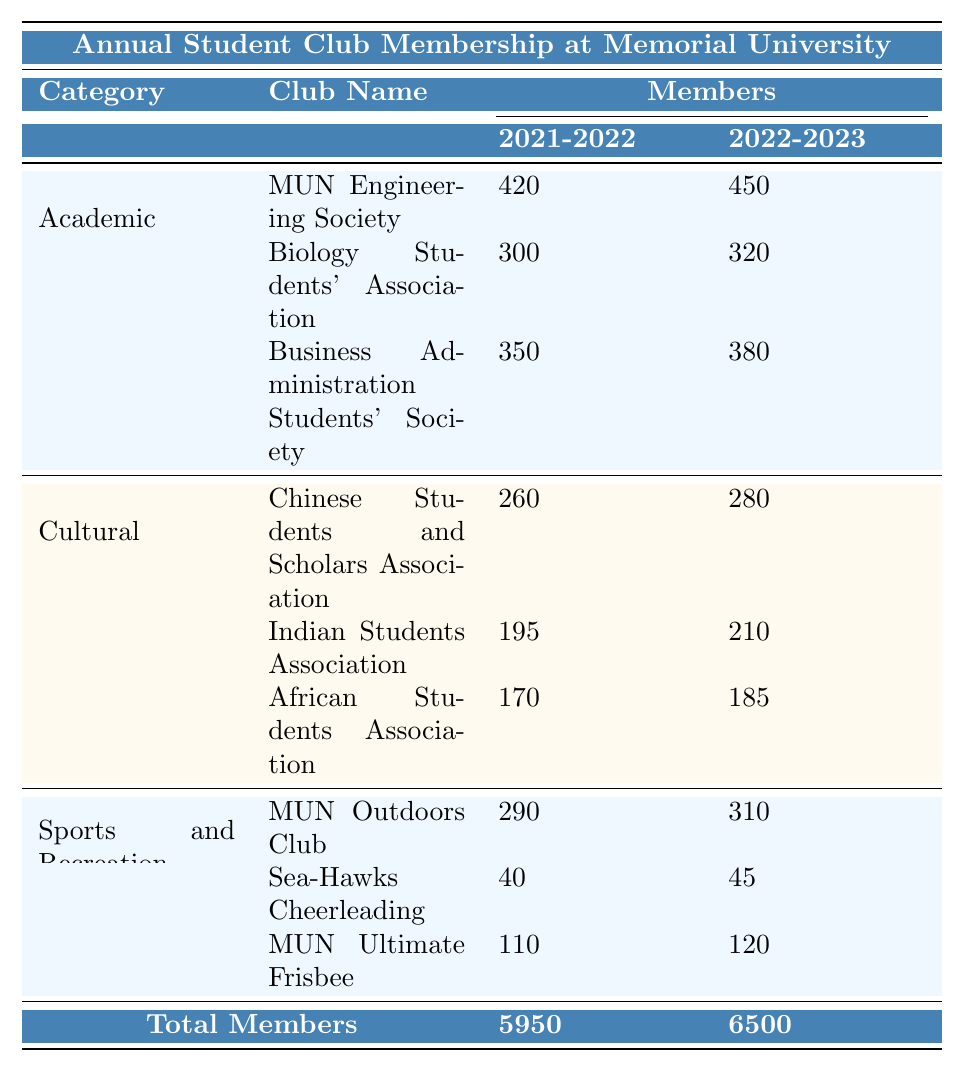What was the total number of clubs at Memorial University in the academic year 2022-2023? The table clearly states that the total number of clubs for the academic year 2022-2023 is 150.
Answer: 150 Which club had the highest membership in the Cultural category for the year 2022-2023? In the Cultural category for 2022-2023, the Chinese Students and Scholars Association had 280 members, which is higher than the other clubs in that category.
Answer: Chinese Students and Scholars Association How many members were in the Sports and Recreation category in 2021-2022? The total number of members in the Sports and Recreation category for 2021-2022 is stated as 2000 in the table.
Answer: 2000 What is the difference in total membership between Academic clubs from 2021-2022 and 2022-2023? In 2021-2022, the total membership in Academic clubs was 2300, and in 2022-2023 it increased to 2500. The difference is 2500 - 2300 = 200.
Answer: 200 Did the total number of clubs increase from 2021-2022 to 2022-2023? The table indicates there were 140 clubs in 2021-2022 and 150 in 2022-2023, which means the total number of clubs did increase.
Answer: Yes What was the total membership for all clubs combined in both academic years? For the year 2021-2022, the total membership was 5950 (Academic 2300 + Cultural 1650 + Sports 2000) and for 2022-2023 it was 6500 (Academic 2500 + Cultural 1800 + Sports 2200). Therefore, combined total is 5950 + 6500 = 12450.
Answer: 12450 Which category experienced the most significant increase in membership between 2021-2022 and 2022-2023, and by how much? The Sports and Recreation category increased from 2000 members in 2021-2022 to 2200 members in 2022-2023, resulting in an increase of 200 members. This is higher than the increase in Academic (200) and Cultural (150) categories.
Answer: Sports and Recreation, 200 What is the average number of members in the clubs under the Academic category for the year 2022-2023? The total membership for Academic clubs in 2022-2023 is 2500 and there are 3 clubs. Average = 2500 / 3 ≈ 833.33, rounding gives approximately 833 members per club.
Answer: 833 Which club had the lowest membership in 2021-2022 and what was the number of its members? The Sea-Hawks Cheerleading club had the lowest membership in 2021-2022 with 40 members.
Answer: Sea-Hawks Cheerleading, 40 How many members did the Business Administration Students' Society gain from 2021-2022 to 2022-2023? In 2021-2022, the Business Administration Students' Society had 350 members and in 2022-2023 it increased to 380. The gain is 380 - 350 = 30 members.
Answer: 30 